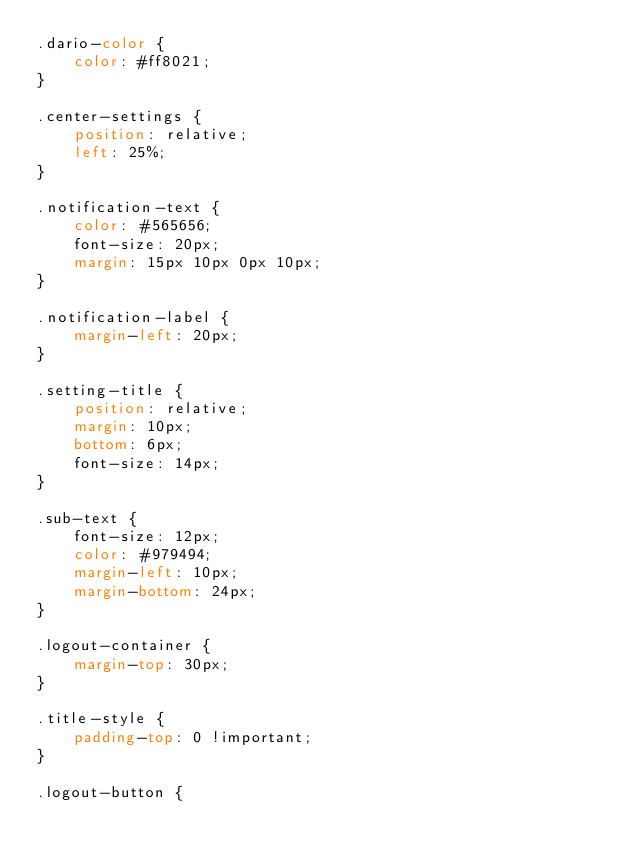<code> <loc_0><loc_0><loc_500><loc_500><_CSS_>.dario-color {
    color: #ff8021;
}

.center-settings {
    position: relative;
    left: 25%;
}

.notification-text {
    color: #565656;
    font-size: 20px;
    margin: 15px 10px 0px 10px;
}

.notification-label {
    margin-left: 20px;
}

.setting-title {
    position: relative;
    margin: 10px;
    bottom: 6px;
    font-size: 14px;
}

.sub-text {
    font-size: 12px;
    color: #979494;
    margin-left: 10px;
    margin-bottom: 24px;
}

.logout-container {
    margin-top: 30px;
}

.title-style {
    padding-top: 0 !important;
}

.logout-button {</code> 